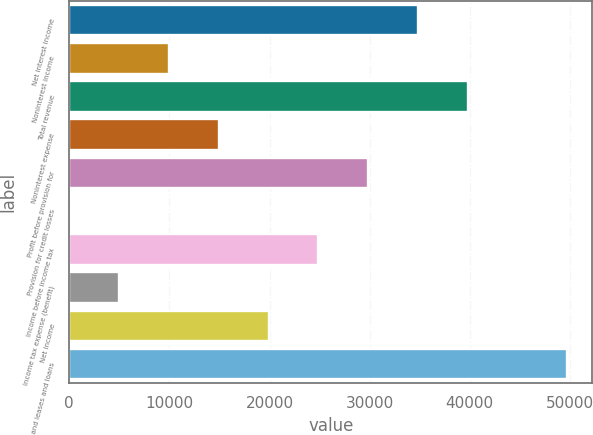<chart> <loc_0><loc_0><loc_500><loc_500><bar_chart><fcel>Net interest income<fcel>Noninterest income<fcel>Total revenue<fcel>Noninterest expense<fcel>Profit before provision for<fcel>Provision for credit losses<fcel>Income before income tax<fcel>Income tax expense (benefit)<fcel>Net income<fcel>Loans and leases and loans<nl><fcel>34828.6<fcel>9964.6<fcel>39801.4<fcel>14937.4<fcel>29855.8<fcel>19<fcel>24883<fcel>4991.8<fcel>19910.2<fcel>49747<nl></chart> 